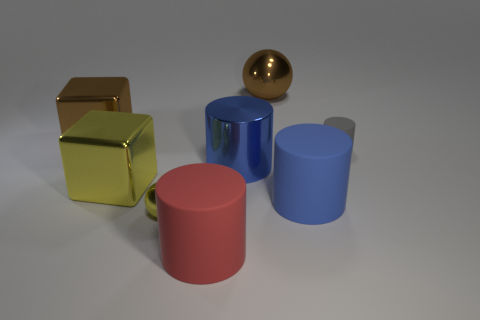There is a metallic block that is behind the tiny gray object; what number of tiny metal balls are on the right side of it? 1 